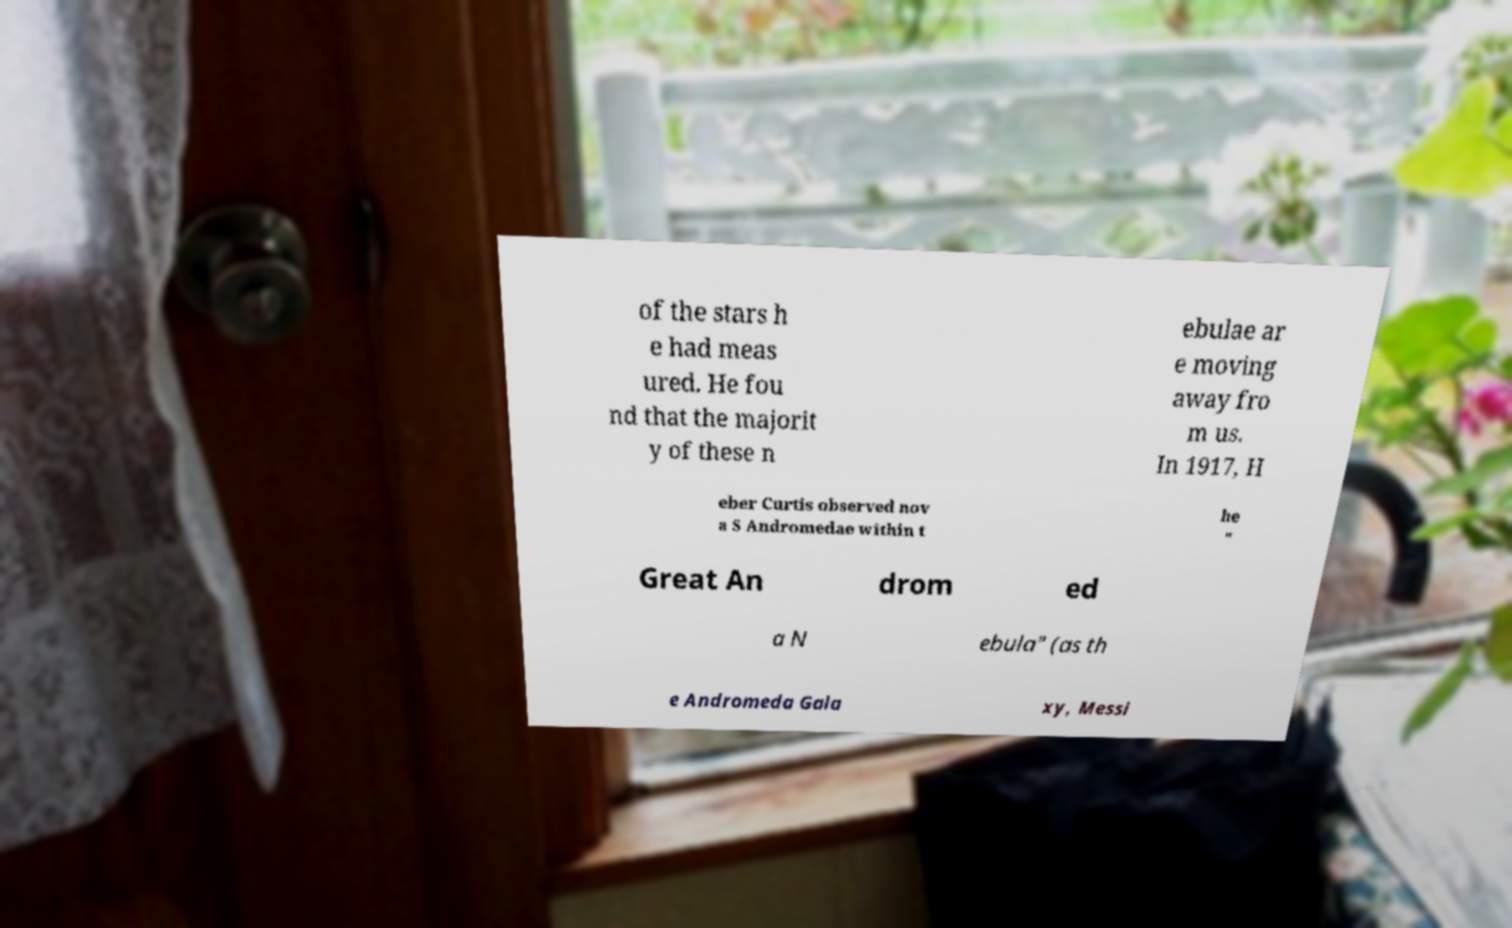There's text embedded in this image that I need extracted. Can you transcribe it verbatim? of the stars h e had meas ured. He fou nd that the majorit y of these n ebulae ar e moving away fro m us. In 1917, H eber Curtis observed nov a S Andromedae within t he " Great An drom ed a N ebula" (as th e Andromeda Gala xy, Messi 